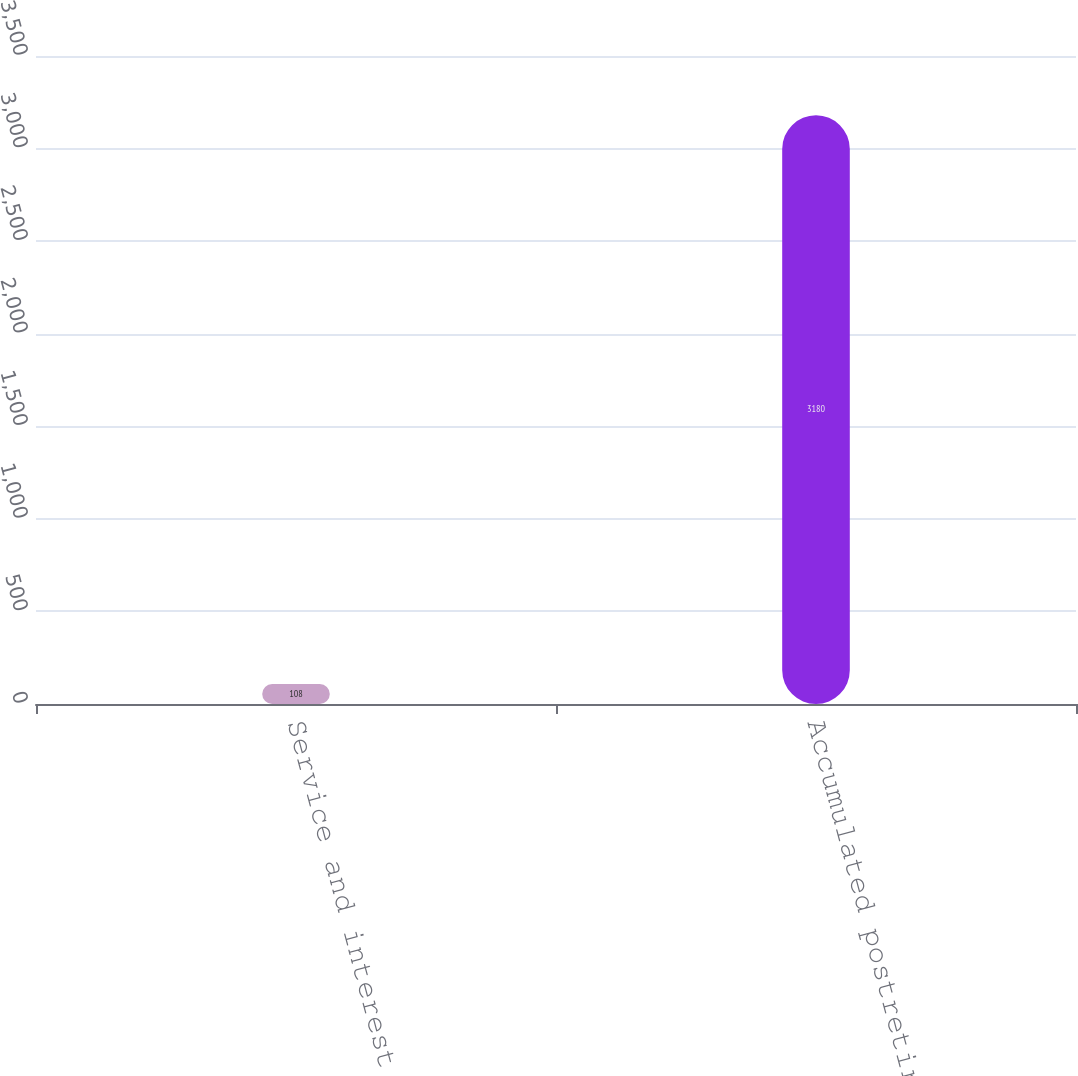Convert chart. <chart><loc_0><loc_0><loc_500><loc_500><bar_chart><fcel>Service and interest cost<fcel>Accumulated postretirement<nl><fcel>108<fcel>3180<nl></chart> 